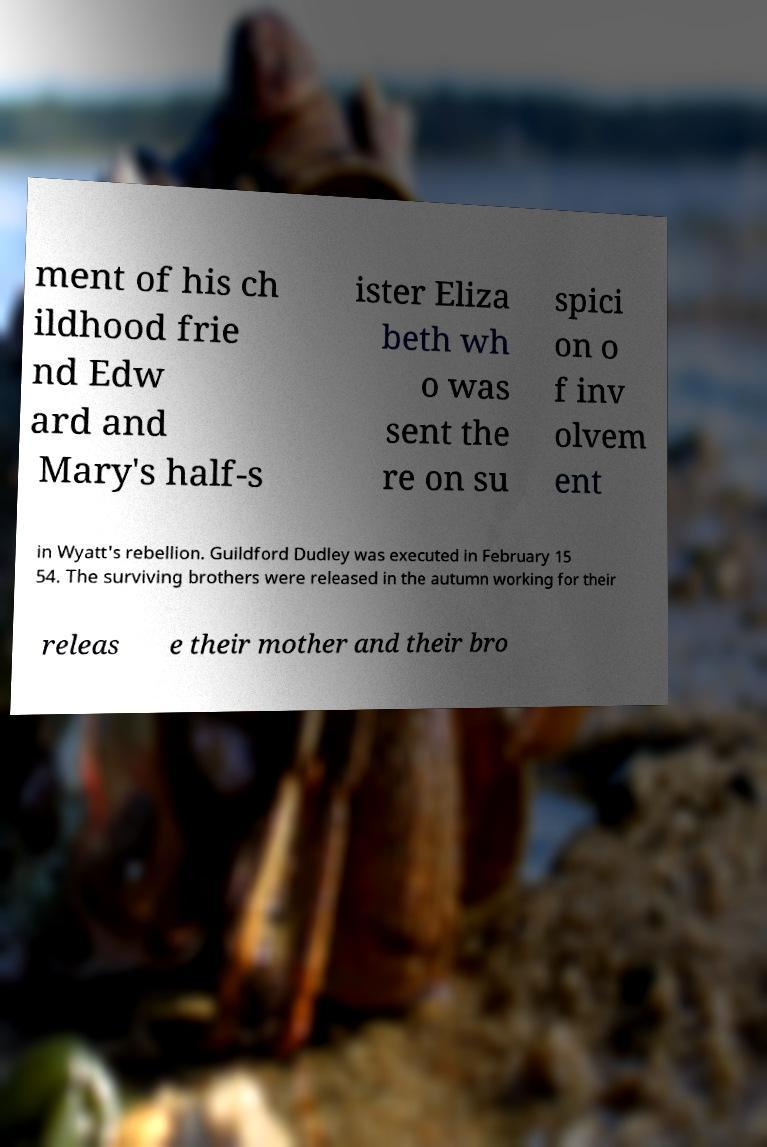For documentation purposes, I need the text within this image transcribed. Could you provide that? ment of his ch ildhood frie nd Edw ard and Mary's half-s ister Eliza beth wh o was sent the re on su spici on o f inv olvem ent in Wyatt's rebellion. Guildford Dudley was executed in February 15 54. The surviving brothers were released in the autumn working for their releas e their mother and their bro 